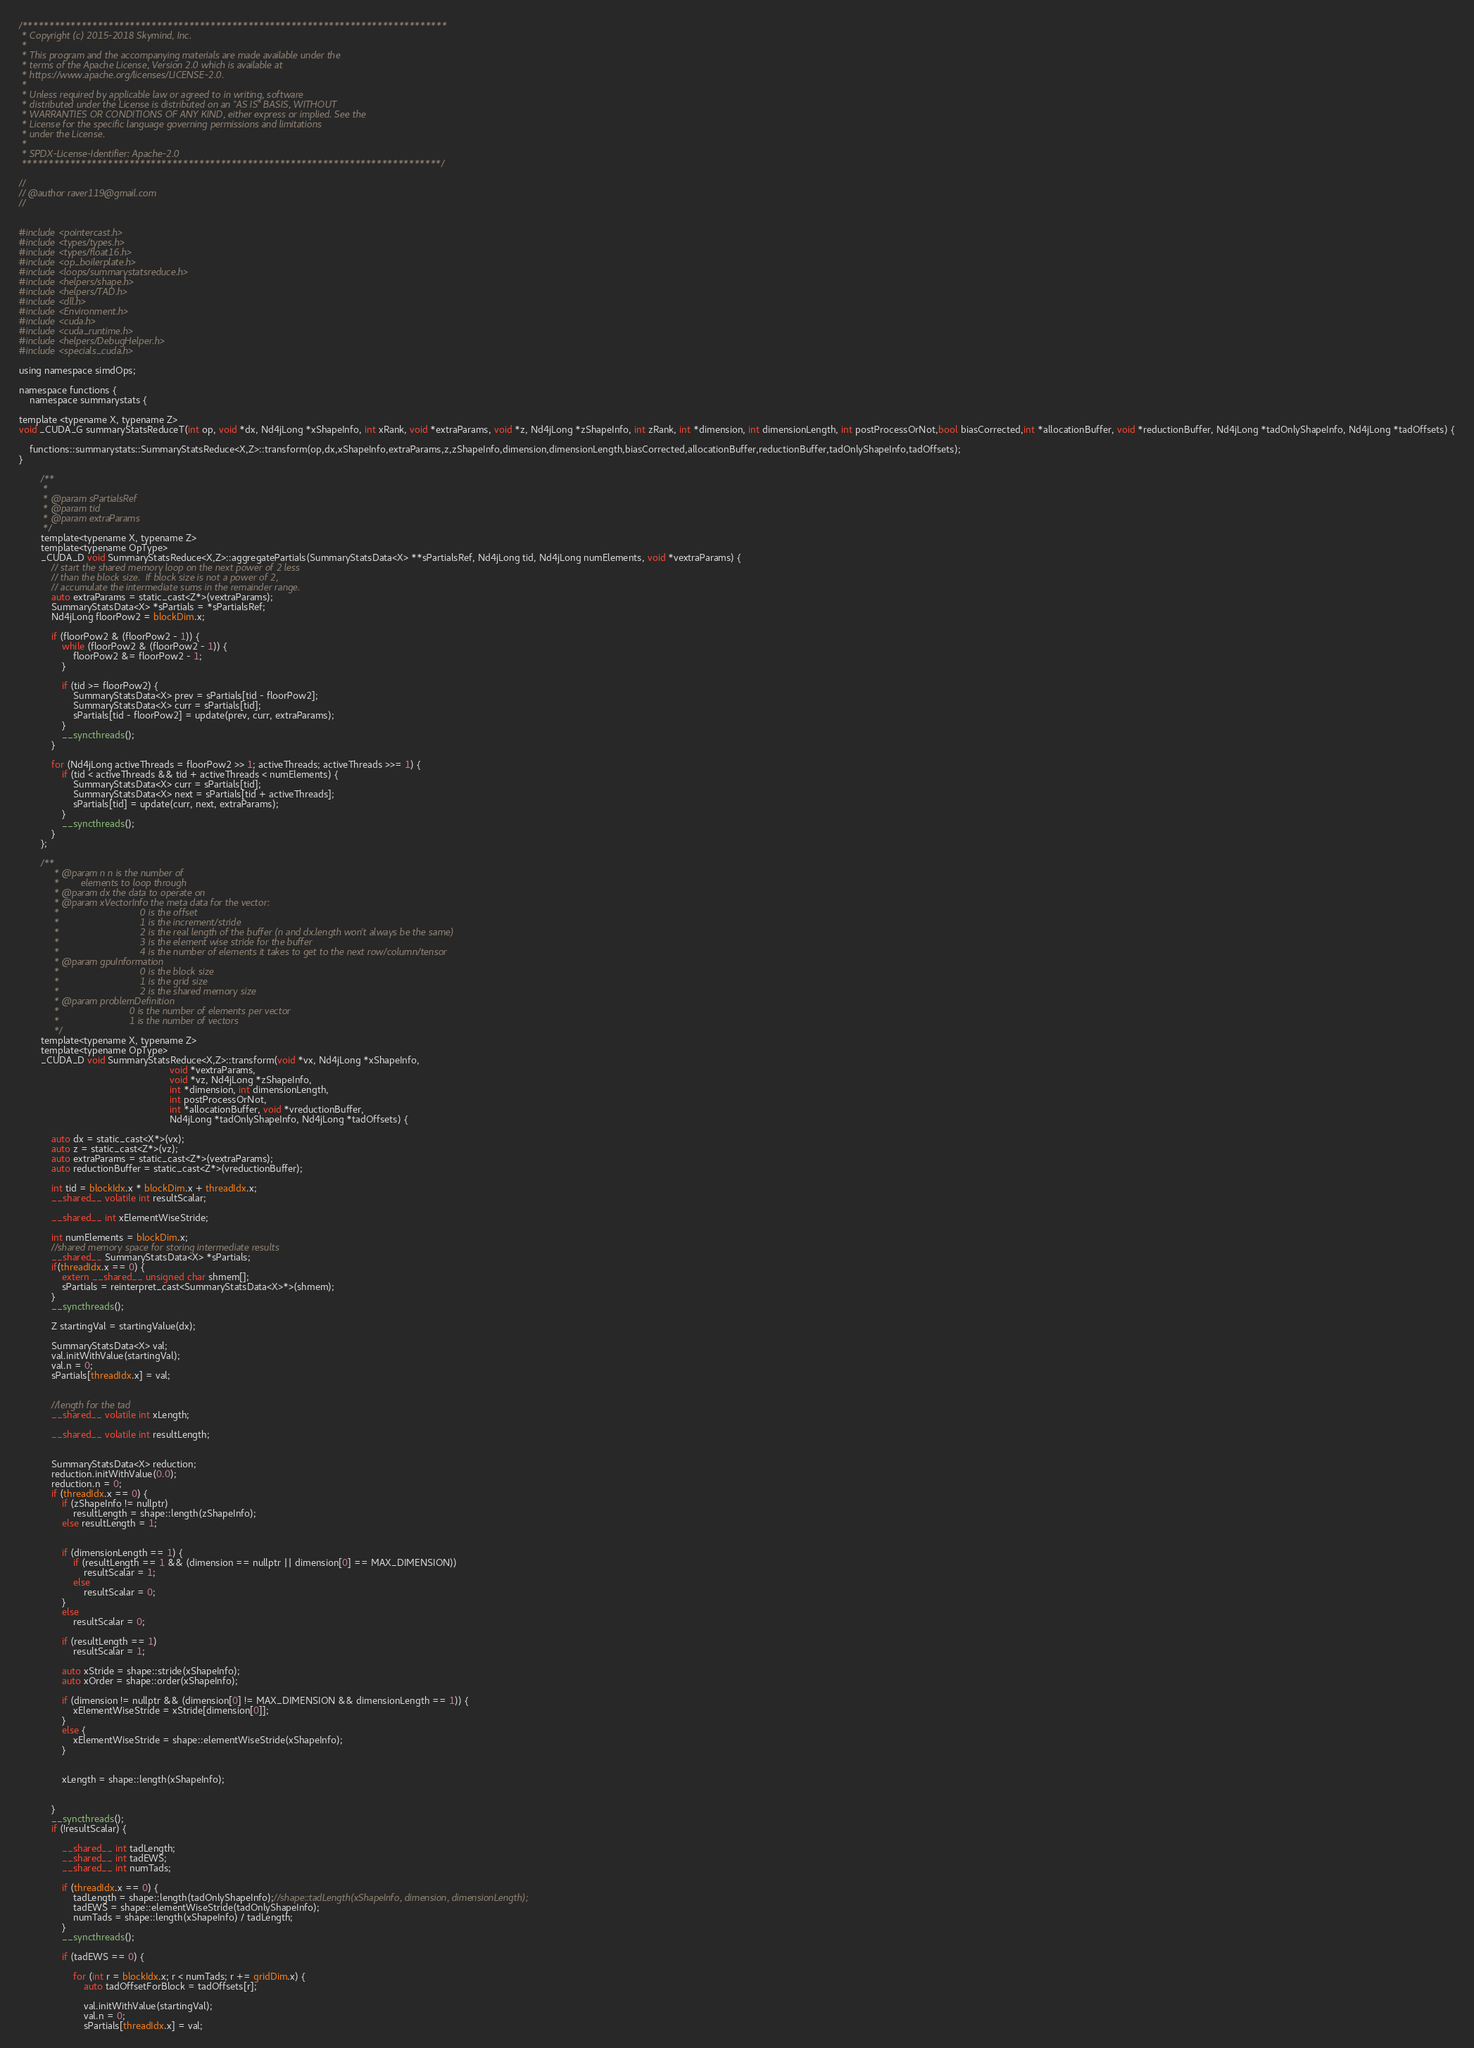Convert code to text. <code><loc_0><loc_0><loc_500><loc_500><_Cuda_>/*******************************************************************************
 * Copyright (c) 2015-2018 Skymind, Inc.
 *
 * This program and the accompanying materials are made available under the
 * terms of the Apache License, Version 2.0 which is available at
 * https://www.apache.org/licenses/LICENSE-2.0.
 *
 * Unless required by applicable law or agreed to in writing, software
 * distributed under the License is distributed on an "AS IS" BASIS, WITHOUT
 * WARRANTIES OR CONDITIONS OF ANY KIND, either express or implied. See the
 * License for the specific language governing permissions and limitations
 * under the License.
 *
 * SPDX-License-Identifier: Apache-2.0
 ******************************************************************************/

//
// @author raver119@gmail.com
//


#include <pointercast.h>
#include <types/types.h>
#include <types/float16.h>
#include <op_boilerplate.h>
#include <loops/summarystatsreduce.h>
#include <helpers/shape.h>
#include <helpers/TAD.h>
#include <dll.h>
#include <Environment.h>
#include <cuda.h>
#include <cuda_runtime.h>
#include <helpers/DebugHelper.h>
#include <specials_cuda.h>

using namespace simdOps;

namespace functions {
    namespace summarystats {

template <typename X, typename Z>
void _CUDA_G summaryStatsReduceT(int op, void *dx, Nd4jLong *xShapeInfo, int xRank, void *extraParams, void *z, Nd4jLong *zShapeInfo, int zRank, int *dimension, int dimensionLength, int postProcessOrNot,bool biasCorrected,int *allocationBuffer, void *reductionBuffer, Nd4jLong *tadOnlyShapeInfo, Nd4jLong *tadOffsets) {
            
    functions::summarystats::SummaryStatsReduce<X,Z>::transform(op,dx,xShapeInfo,extraParams,z,zShapeInfo,dimension,dimensionLength,biasCorrected,allocationBuffer,reductionBuffer,tadOnlyShapeInfo,tadOffsets);
}

        /**
		 *
		 * @param sPartialsRef
		 * @param tid
		 * @param extraParams
		 */
        template<typename X, typename Z>
        template<typename OpType>
        _CUDA_D void SummaryStatsReduce<X,Z>::aggregatePartials(SummaryStatsData<X> **sPartialsRef, Nd4jLong tid, Nd4jLong numElements, void *vextraParams) {
            // start the shared memory loop on the next power of 2 less
            // than the block size.  If block size is not a power of 2,
            // accumulate the intermediate sums in the remainder range.
            auto extraParams = static_cast<Z*>(vextraParams);
            SummaryStatsData<X> *sPartials = *sPartialsRef;
            Nd4jLong floorPow2 = blockDim.x;

            if (floorPow2 & (floorPow2 - 1)) {
                while (floorPow2 & (floorPow2 - 1)) {
                    floorPow2 &= floorPow2 - 1;
                }

                if (tid >= floorPow2) {
                    SummaryStatsData<X> prev = sPartials[tid - floorPow2];
                    SummaryStatsData<X> curr = sPartials[tid];
                    sPartials[tid - floorPow2] = update(prev, curr, extraParams);
                }
                __syncthreads();
            }

            for (Nd4jLong activeThreads = floorPow2 >> 1; activeThreads; activeThreads >>= 1) {
                if (tid < activeThreads && tid + activeThreads < numElements) {
                    SummaryStatsData<X> curr = sPartials[tid];
                    SummaryStatsData<X> next = sPartials[tid + activeThreads];
                    sPartials[tid] = update(curr, next, extraParams);
                }
                __syncthreads();
            }
        };

        /**
			 * @param n n is the number of
			 *        elements to loop through
			 * @param dx the data to operate on
			 * @param xVectorInfo the meta data for the vector:
			 *                              0 is the offset
			 *                              1 is the increment/stride
			 *                              2 is the real length of the buffer (n and dx.length won't always be the same)
			 *                              3 is the element wise stride for the buffer
			 *                              4 is the number of elements it takes to get to the next row/column/tensor
			 * @param gpuInformation
			 *                              0 is the block size
			 *                              1 is the grid size
			 *                              2 is the shared memory size
			 * @param problemDefinition
			 *                          0 is the number of elements per vector
			 *                          1 is the number of vectors
			 */
        template<typename X, typename Z>
        template<typename OpType>
        _CUDA_D void SummaryStatsReduce<X,Z>::transform(void *vx, Nd4jLong *xShapeInfo, 
                                                        void *vextraParams, 
                                                        void *vz, Nd4jLong *zShapeInfo, 
                                                        int *dimension, int dimensionLength, 
                                                        int postProcessOrNot, 
                                                        int *allocationBuffer, void *vreductionBuffer, 
                                                        Nd4jLong *tadOnlyShapeInfo, Nd4jLong *tadOffsets) {

            auto dx = static_cast<X*>(vx);
            auto z = static_cast<Z*>(vz);
            auto extraParams = static_cast<Z*>(vextraParams);
            auto reductionBuffer = static_cast<Z*>(vreductionBuffer);

            int tid = blockIdx.x * blockDim.x + threadIdx.x;
            __shared__ volatile int resultScalar;

            __shared__ int xElementWiseStride;

            int numElements = blockDim.x;
            //shared memory space for storing intermediate results
            __shared__ SummaryStatsData<X> *sPartials;
            if(threadIdx.x == 0) {
                extern __shared__ unsigned char shmem[];
                sPartials = reinterpret_cast<SummaryStatsData<X>*>(shmem);
            }
            __syncthreads();

            Z startingVal = startingValue(dx);

            SummaryStatsData<X> val;
            val.initWithValue(startingVal);
            val.n = 0;
            sPartials[threadIdx.x] = val;


            //length for the tad
            __shared__ volatile int xLength;

            __shared__ volatile int resultLength;


            SummaryStatsData<X> reduction;
            reduction.initWithValue(0.0);
            reduction.n = 0;
            if (threadIdx.x == 0) {
                if (zShapeInfo != nullptr)
                    resultLength = shape::length(zShapeInfo);
                else resultLength = 1;


                if (dimensionLength == 1) {
                    if (resultLength == 1 && (dimension == nullptr || dimension[0] == MAX_DIMENSION))
                        resultScalar = 1;
                    else
                        resultScalar = 0;
                }
                else
                    resultScalar = 0;

                if (resultLength == 1)
                    resultScalar = 1;

                auto xStride = shape::stride(xShapeInfo);
                auto xOrder = shape::order(xShapeInfo);

                if (dimension != nullptr && (dimension[0] != MAX_DIMENSION && dimensionLength == 1)) {
                    xElementWiseStride = xStride[dimension[0]];
                }
                else {
                    xElementWiseStride = shape::elementWiseStride(xShapeInfo);
                }


                xLength = shape::length(xShapeInfo);


            }
            __syncthreads();
            if (!resultScalar) {

                __shared__ int tadLength;
                __shared__ int tadEWS;
                __shared__ int numTads;

                if (threadIdx.x == 0) {
                    tadLength = shape::length(tadOnlyShapeInfo);//shape::tadLength(xShapeInfo, dimension, dimensionLength);
                    tadEWS = shape::elementWiseStride(tadOnlyShapeInfo);
                    numTads = shape::length(xShapeInfo) / tadLength;
                }
                __syncthreads();

                if (tadEWS == 0) {

                    for (int r = blockIdx.x; r < numTads; r += gridDim.x) {
                        auto tadOffsetForBlock = tadOffsets[r];

                        val.initWithValue(startingVal);
                        val.n = 0;
                        sPartials[threadIdx.x] = val;
</code> 